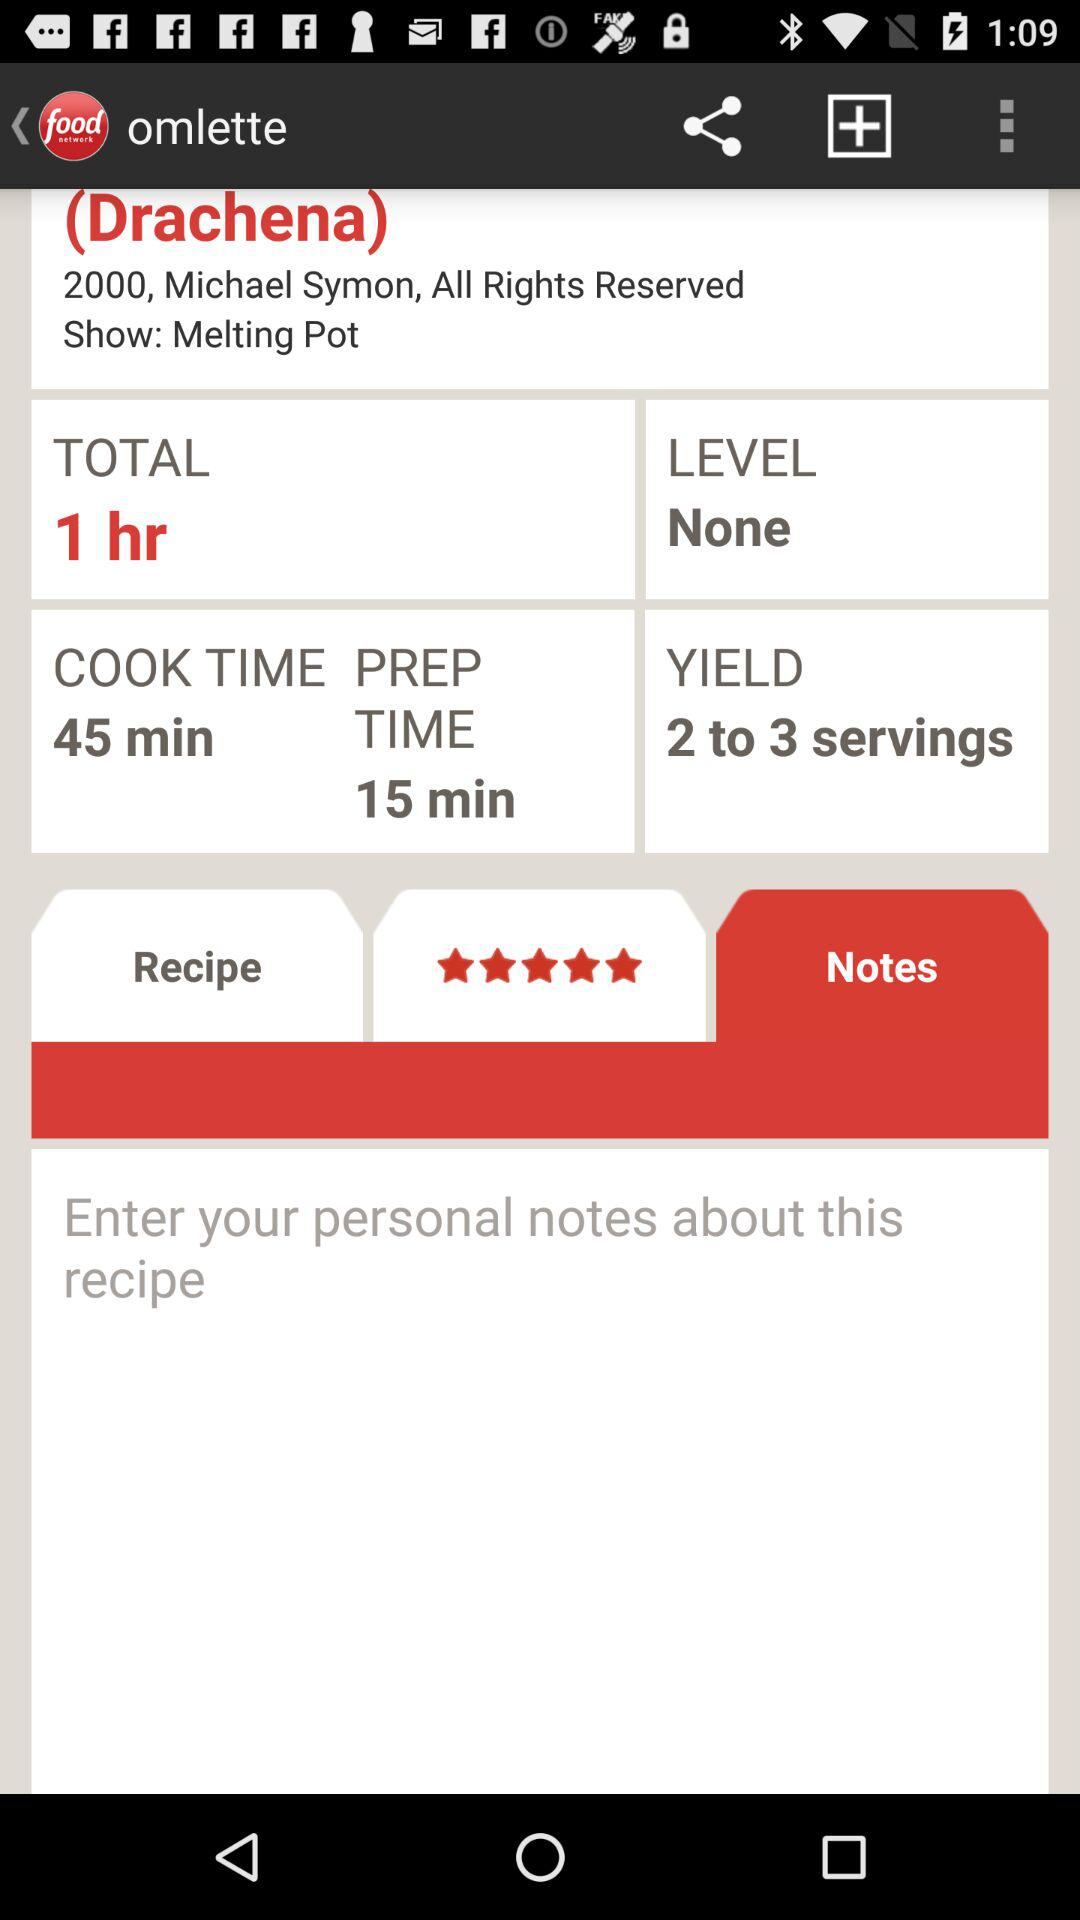What are the total hours? The total hour is 1. 